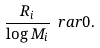Convert formula to latex. <formula><loc_0><loc_0><loc_500><loc_500>\frac { R _ { i } } { \log M _ { i } } \ r a r 0 .</formula> 